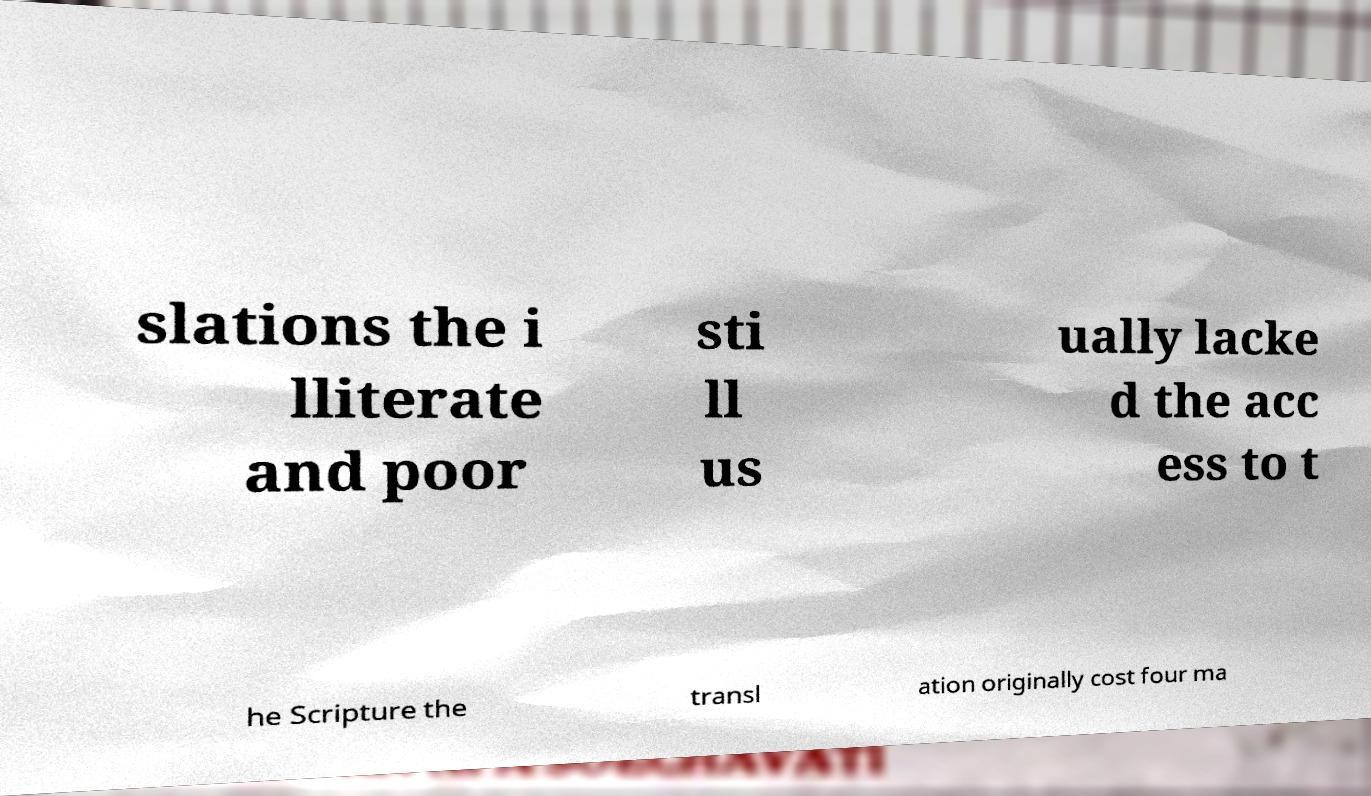Could you assist in decoding the text presented in this image and type it out clearly? slations the i lliterate and poor sti ll us ually lacke d the acc ess to t he Scripture the transl ation originally cost four ma 